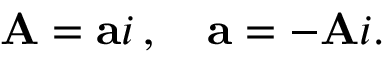Convert formula to latex. <formula><loc_0><loc_0><loc_500><loc_500>A = a i \, , \quad a = - A i .</formula> 